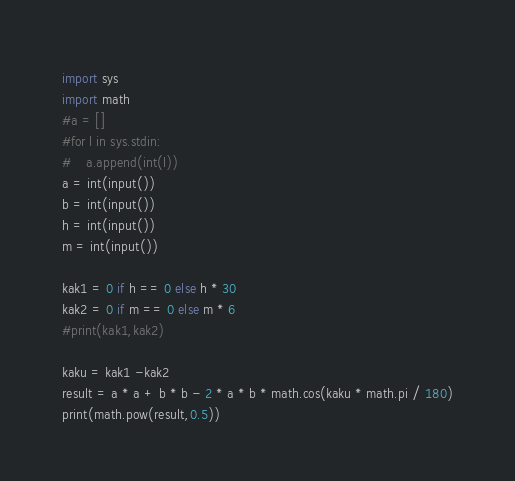<code> <loc_0><loc_0><loc_500><loc_500><_Python_>import sys
import math
#a = []
#for l in sys.stdin:
#    a.append(int(l))
a = int(input())
b = int(input())
h = int(input())
m = int(input())

kak1 = 0 if h == 0 else h * 30
kak2 = 0 if m == 0 else m * 6
#print(kak1,kak2)

kaku = kak1 -kak2
result = a * a + b * b - 2 * a * b * math.cos(kaku * math.pi / 180)
print(math.pow(result,0.5))</code> 